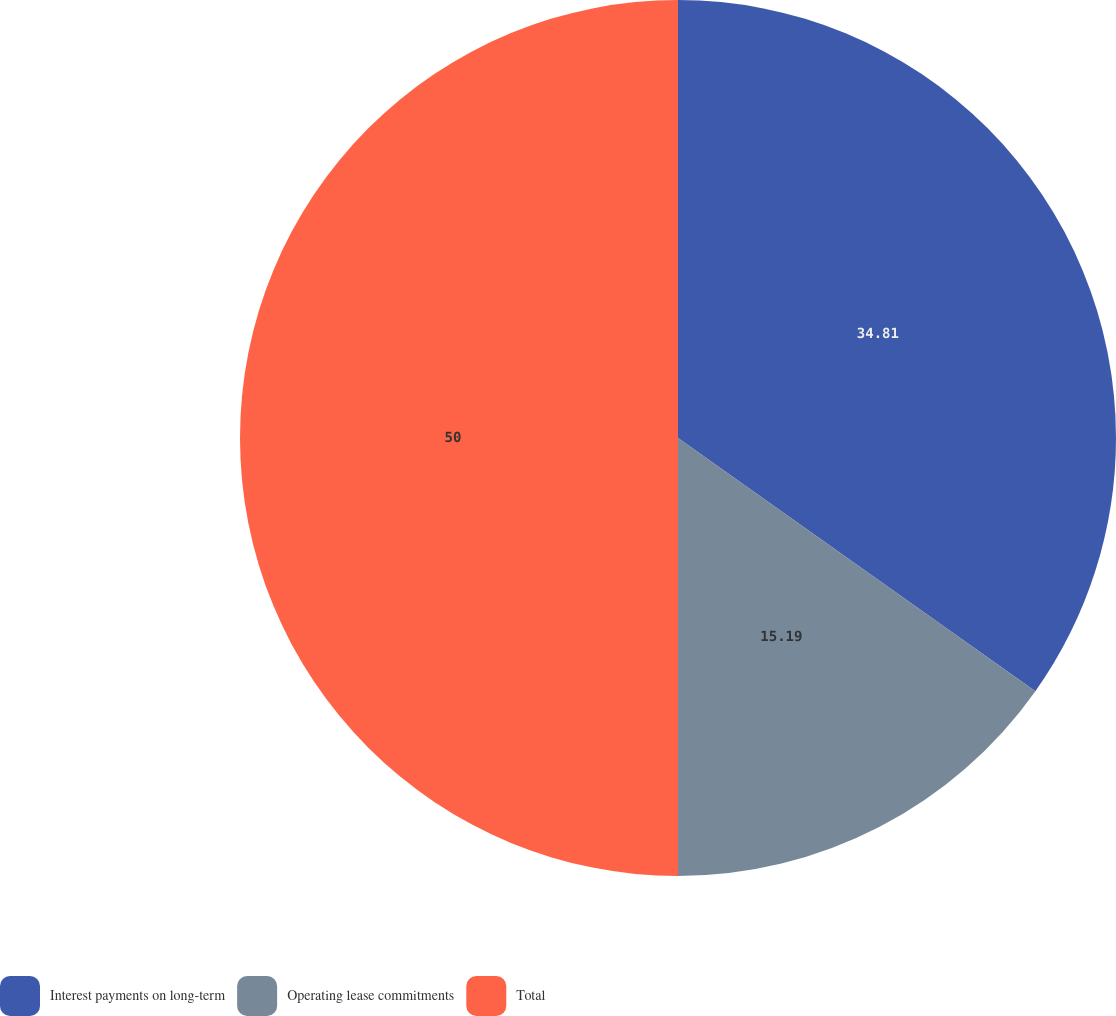Convert chart. <chart><loc_0><loc_0><loc_500><loc_500><pie_chart><fcel>Interest payments on long-term<fcel>Operating lease commitments<fcel>Total<nl><fcel>34.81%<fcel>15.19%<fcel>50.0%<nl></chart> 